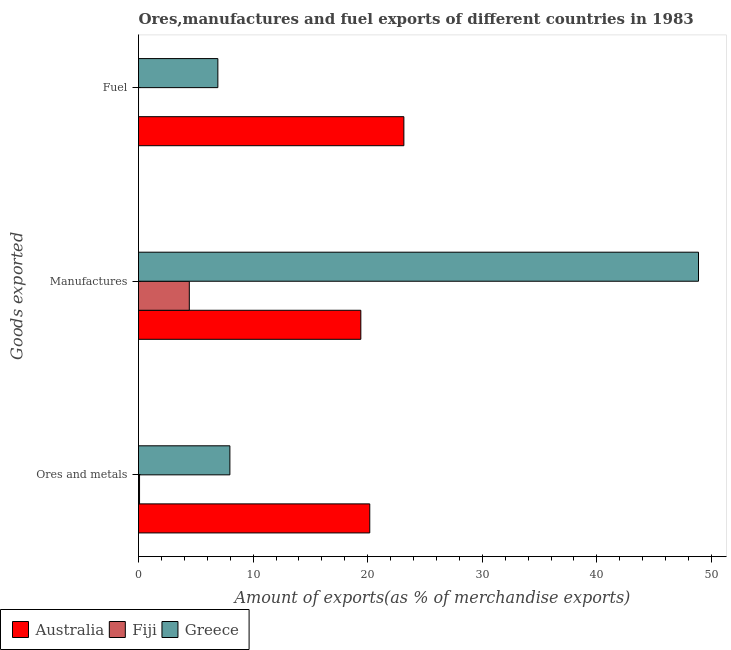How many groups of bars are there?
Provide a succinct answer. 3. Are the number of bars per tick equal to the number of legend labels?
Your answer should be very brief. Yes. Are the number of bars on each tick of the Y-axis equal?
Provide a succinct answer. Yes. How many bars are there on the 3rd tick from the top?
Offer a terse response. 3. What is the label of the 2nd group of bars from the top?
Keep it short and to the point. Manufactures. What is the percentage of ores and metals exports in Fiji?
Your answer should be very brief. 0.09. Across all countries, what is the maximum percentage of manufactures exports?
Your response must be concise. 48.87. Across all countries, what is the minimum percentage of fuel exports?
Ensure brevity in your answer.  0. In which country was the percentage of manufactures exports maximum?
Make the answer very short. Greece. In which country was the percentage of fuel exports minimum?
Your answer should be very brief. Fiji. What is the total percentage of manufactures exports in the graph?
Offer a terse response. 72.7. What is the difference between the percentage of manufactures exports in Fiji and that in Greece?
Make the answer very short. -44.43. What is the difference between the percentage of manufactures exports in Fiji and the percentage of ores and metals exports in Greece?
Provide a succinct answer. -3.54. What is the average percentage of ores and metals exports per country?
Provide a succinct answer. 9.42. What is the difference between the percentage of ores and metals exports and percentage of fuel exports in Greece?
Make the answer very short. 1.05. What is the ratio of the percentage of ores and metals exports in Fiji to that in Australia?
Offer a terse response. 0. What is the difference between the highest and the second highest percentage of ores and metals exports?
Ensure brevity in your answer.  12.21. What is the difference between the highest and the lowest percentage of manufactures exports?
Provide a succinct answer. 44.43. In how many countries, is the percentage of manufactures exports greater than the average percentage of manufactures exports taken over all countries?
Your answer should be very brief. 1. What does the 1st bar from the top in Manufactures represents?
Provide a succinct answer. Greece. Is it the case that in every country, the sum of the percentage of ores and metals exports and percentage of manufactures exports is greater than the percentage of fuel exports?
Ensure brevity in your answer.  Yes. Are all the bars in the graph horizontal?
Your answer should be compact. Yes. What is the difference between two consecutive major ticks on the X-axis?
Offer a very short reply. 10. Does the graph contain any zero values?
Your answer should be compact. No. Does the graph contain grids?
Offer a very short reply. No. Where does the legend appear in the graph?
Provide a short and direct response. Bottom left. How many legend labels are there?
Provide a succinct answer. 3. What is the title of the graph?
Provide a succinct answer. Ores,manufactures and fuel exports of different countries in 1983. Does "Georgia" appear as one of the legend labels in the graph?
Your response must be concise. No. What is the label or title of the X-axis?
Keep it short and to the point. Amount of exports(as % of merchandise exports). What is the label or title of the Y-axis?
Offer a very short reply. Goods exported. What is the Amount of exports(as % of merchandise exports) of Australia in Ores and metals?
Offer a very short reply. 20.18. What is the Amount of exports(as % of merchandise exports) of Fiji in Ores and metals?
Offer a terse response. 0.09. What is the Amount of exports(as % of merchandise exports) in Greece in Ores and metals?
Your answer should be very brief. 7.97. What is the Amount of exports(as % of merchandise exports) of Australia in Manufactures?
Your answer should be compact. 19.4. What is the Amount of exports(as % of merchandise exports) in Fiji in Manufactures?
Offer a terse response. 4.43. What is the Amount of exports(as % of merchandise exports) of Greece in Manufactures?
Provide a succinct answer. 48.87. What is the Amount of exports(as % of merchandise exports) in Australia in Fuel?
Offer a terse response. 23.16. What is the Amount of exports(as % of merchandise exports) of Fiji in Fuel?
Keep it short and to the point. 0. What is the Amount of exports(as % of merchandise exports) in Greece in Fuel?
Give a very brief answer. 6.92. Across all Goods exported, what is the maximum Amount of exports(as % of merchandise exports) of Australia?
Ensure brevity in your answer.  23.16. Across all Goods exported, what is the maximum Amount of exports(as % of merchandise exports) in Fiji?
Provide a succinct answer. 4.43. Across all Goods exported, what is the maximum Amount of exports(as % of merchandise exports) of Greece?
Ensure brevity in your answer.  48.87. Across all Goods exported, what is the minimum Amount of exports(as % of merchandise exports) of Australia?
Provide a succinct answer. 19.4. Across all Goods exported, what is the minimum Amount of exports(as % of merchandise exports) of Fiji?
Offer a very short reply. 0. Across all Goods exported, what is the minimum Amount of exports(as % of merchandise exports) in Greece?
Ensure brevity in your answer.  6.92. What is the total Amount of exports(as % of merchandise exports) of Australia in the graph?
Provide a short and direct response. 62.74. What is the total Amount of exports(as % of merchandise exports) in Fiji in the graph?
Ensure brevity in your answer.  4.52. What is the total Amount of exports(as % of merchandise exports) in Greece in the graph?
Your answer should be very brief. 63.77. What is the difference between the Amount of exports(as % of merchandise exports) of Australia in Ores and metals and that in Manufactures?
Offer a terse response. 0.78. What is the difference between the Amount of exports(as % of merchandise exports) of Fiji in Ores and metals and that in Manufactures?
Ensure brevity in your answer.  -4.34. What is the difference between the Amount of exports(as % of merchandise exports) in Greece in Ores and metals and that in Manufactures?
Offer a very short reply. -40.89. What is the difference between the Amount of exports(as % of merchandise exports) in Australia in Ores and metals and that in Fuel?
Your answer should be compact. -2.98. What is the difference between the Amount of exports(as % of merchandise exports) in Fiji in Ores and metals and that in Fuel?
Provide a succinct answer. 0.09. What is the difference between the Amount of exports(as % of merchandise exports) of Greece in Ores and metals and that in Fuel?
Provide a succinct answer. 1.05. What is the difference between the Amount of exports(as % of merchandise exports) of Australia in Manufactures and that in Fuel?
Make the answer very short. -3.76. What is the difference between the Amount of exports(as % of merchandise exports) in Fiji in Manufactures and that in Fuel?
Your answer should be very brief. 4.43. What is the difference between the Amount of exports(as % of merchandise exports) in Greece in Manufactures and that in Fuel?
Make the answer very short. 41.94. What is the difference between the Amount of exports(as % of merchandise exports) in Australia in Ores and metals and the Amount of exports(as % of merchandise exports) in Fiji in Manufactures?
Give a very brief answer. 15.75. What is the difference between the Amount of exports(as % of merchandise exports) of Australia in Ores and metals and the Amount of exports(as % of merchandise exports) of Greece in Manufactures?
Make the answer very short. -28.69. What is the difference between the Amount of exports(as % of merchandise exports) of Fiji in Ores and metals and the Amount of exports(as % of merchandise exports) of Greece in Manufactures?
Ensure brevity in your answer.  -48.78. What is the difference between the Amount of exports(as % of merchandise exports) of Australia in Ores and metals and the Amount of exports(as % of merchandise exports) of Fiji in Fuel?
Your answer should be compact. 20.18. What is the difference between the Amount of exports(as % of merchandise exports) of Australia in Ores and metals and the Amount of exports(as % of merchandise exports) of Greece in Fuel?
Your answer should be compact. 13.26. What is the difference between the Amount of exports(as % of merchandise exports) in Fiji in Ores and metals and the Amount of exports(as % of merchandise exports) in Greece in Fuel?
Provide a short and direct response. -6.83. What is the difference between the Amount of exports(as % of merchandise exports) in Australia in Manufactures and the Amount of exports(as % of merchandise exports) in Fiji in Fuel?
Offer a terse response. 19.4. What is the difference between the Amount of exports(as % of merchandise exports) of Australia in Manufactures and the Amount of exports(as % of merchandise exports) of Greece in Fuel?
Your answer should be compact. 12.48. What is the difference between the Amount of exports(as % of merchandise exports) of Fiji in Manufactures and the Amount of exports(as % of merchandise exports) of Greece in Fuel?
Keep it short and to the point. -2.49. What is the average Amount of exports(as % of merchandise exports) in Australia per Goods exported?
Ensure brevity in your answer.  20.91. What is the average Amount of exports(as % of merchandise exports) in Fiji per Goods exported?
Your answer should be very brief. 1.51. What is the average Amount of exports(as % of merchandise exports) in Greece per Goods exported?
Your answer should be compact. 21.25. What is the difference between the Amount of exports(as % of merchandise exports) of Australia and Amount of exports(as % of merchandise exports) of Fiji in Ores and metals?
Provide a short and direct response. 20.09. What is the difference between the Amount of exports(as % of merchandise exports) in Australia and Amount of exports(as % of merchandise exports) in Greece in Ores and metals?
Keep it short and to the point. 12.21. What is the difference between the Amount of exports(as % of merchandise exports) of Fiji and Amount of exports(as % of merchandise exports) of Greece in Ores and metals?
Ensure brevity in your answer.  -7.88. What is the difference between the Amount of exports(as % of merchandise exports) of Australia and Amount of exports(as % of merchandise exports) of Fiji in Manufactures?
Make the answer very short. 14.97. What is the difference between the Amount of exports(as % of merchandise exports) of Australia and Amount of exports(as % of merchandise exports) of Greece in Manufactures?
Ensure brevity in your answer.  -29.47. What is the difference between the Amount of exports(as % of merchandise exports) of Fiji and Amount of exports(as % of merchandise exports) of Greece in Manufactures?
Offer a terse response. -44.43. What is the difference between the Amount of exports(as % of merchandise exports) of Australia and Amount of exports(as % of merchandise exports) of Fiji in Fuel?
Ensure brevity in your answer.  23.16. What is the difference between the Amount of exports(as % of merchandise exports) in Australia and Amount of exports(as % of merchandise exports) in Greece in Fuel?
Offer a terse response. 16.23. What is the difference between the Amount of exports(as % of merchandise exports) of Fiji and Amount of exports(as % of merchandise exports) of Greece in Fuel?
Your answer should be compact. -6.92. What is the ratio of the Amount of exports(as % of merchandise exports) in Australia in Ores and metals to that in Manufactures?
Your answer should be very brief. 1.04. What is the ratio of the Amount of exports(as % of merchandise exports) in Fiji in Ores and metals to that in Manufactures?
Keep it short and to the point. 0.02. What is the ratio of the Amount of exports(as % of merchandise exports) in Greece in Ores and metals to that in Manufactures?
Make the answer very short. 0.16. What is the ratio of the Amount of exports(as % of merchandise exports) of Australia in Ores and metals to that in Fuel?
Your response must be concise. 0.87. What is the ratio of the Amount of exports(as % of merchandise exports) in Fiji in Ores and metals to that in Fuel?
Your response must be concise. 248.73. What is the ratio of the Amount of exports(as % of merchandise exports) of Greece in Ores and metals to that in Fuel?
Give a very brief answer. 1.15. What is the ratio of the Amount of exports(as % of merchandise exports) in Australia in Manufactures to that in Fuel?
Ensure brevity in your answer.  0.84. What is the ratio of the Amount of exports(as % of merchandise exports) in Fiji in Manufactures to that in Fuel?
Your answer should be very brief. 1.22e+04. What is the ratio of the Amount of exports(as % of merchandise exports) of Greece in Manufactures to that in Fuel?
Provide a short and direct response. 7.06. What is the difference between the highest and the second highest Amount of exports(as % of merchandise exports) in Australia?
Your answer should be very brief. 2.98. What is the difference between the highest and the second highest Amount of exports(as % of merchandise exports) in Fiji?
Your answer should be compact. 4.34. What is the difference between the highest and the second highest Amount of exports(as % of merchandise exports) in Greece?
Your answer should be very brief. 40.89. What is the difference between the highest and the lowest Amount of exports(as % of merchandise exports) in Australia?
Your answer should be very brief. 3.76. What is the difference between the highest and the lowest Amount of exports(as % of merchandise exports) of Fiji?
Give a very brief answer. 4.43. What is the difference between the highest and the lowest Amount of exports(as % of merchandise exports) of Greece?
Give a very brief answer. 41.94. 